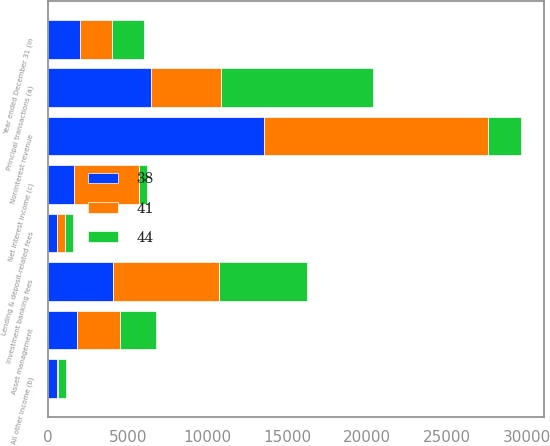Convert chart to OTSL. <chart><loc_0><loc_0><loc_500><loc_500><stacked_bar_chart><ecel><fcel>Year ended December 31 (in<fcel>Investment banking fees<fcel>Principal transactions (a)<fcel>Lending & deposit-related fees<fcel>Asset management<fcel>All other income (b)<fcel>Noninterest revenue<fcel>Net interest income (c)<nl><fcel>41<fcel>2007<fcel>6616<fcel>4409<fcel>446<fcel>2701<fcel>78<fcel>14094<fcel>4076<nl><fcel>44<fcel>2006<fcel>5537<fcel>9512<fcel>517<fcel>2240<fcel>528<fcel>2007<fcel>499<nl><fcel>38<fcel>2005<fcel>4096<fcel>6459<fcel>594<fcel>1824<fcel>534<fcel>13507<fcel>1603<nl></chart> 